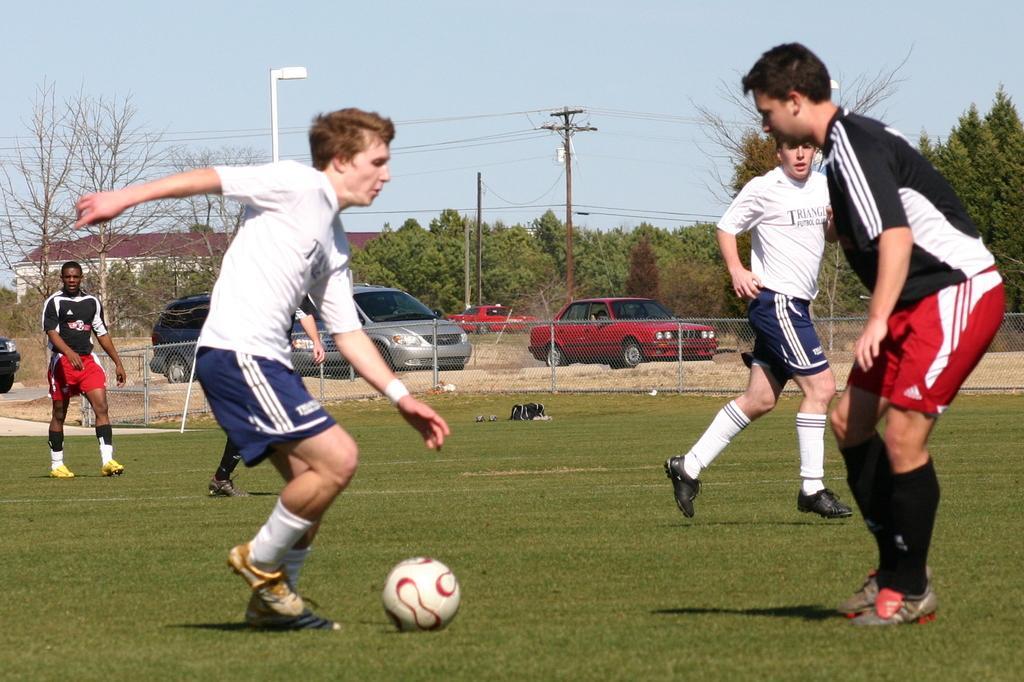In one or two sentences, can you explain what this image depicts? This picture is clicked outside. In the center we can see the group of persons wearing t-shirts and seems to be playing basketball. In the center there is a ball placed on the ground and the ground is covered with the green grass. In the background we can see the mesh, metal rods, group of cars parked on the ground, we can see the sky, poles, cables, trees and houses. 